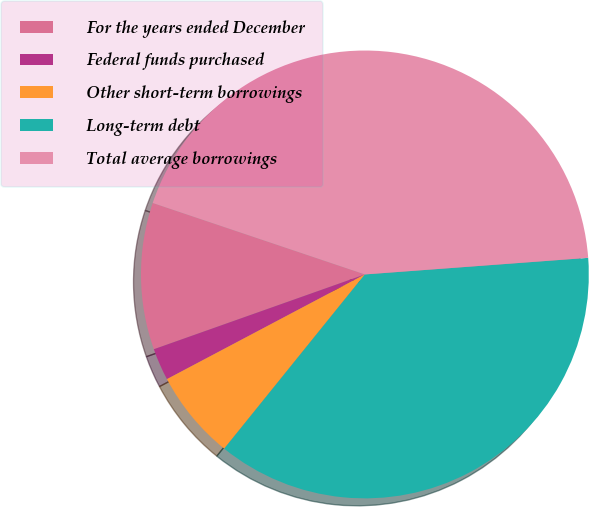<chart> <loc_0><loc_0><loc_500><loc_500><pie_chart><fcel>For the years ended December<fcel>Federal funds purchased<fcel>Other short-term borrowings<fcel>Long-term debt<fcel>Total average borrowings<nl><fcel>10.59%<fcel>2.32%<fcel>6.45%<fcel>36.99%<fcel>43.65%<nl></chart> 